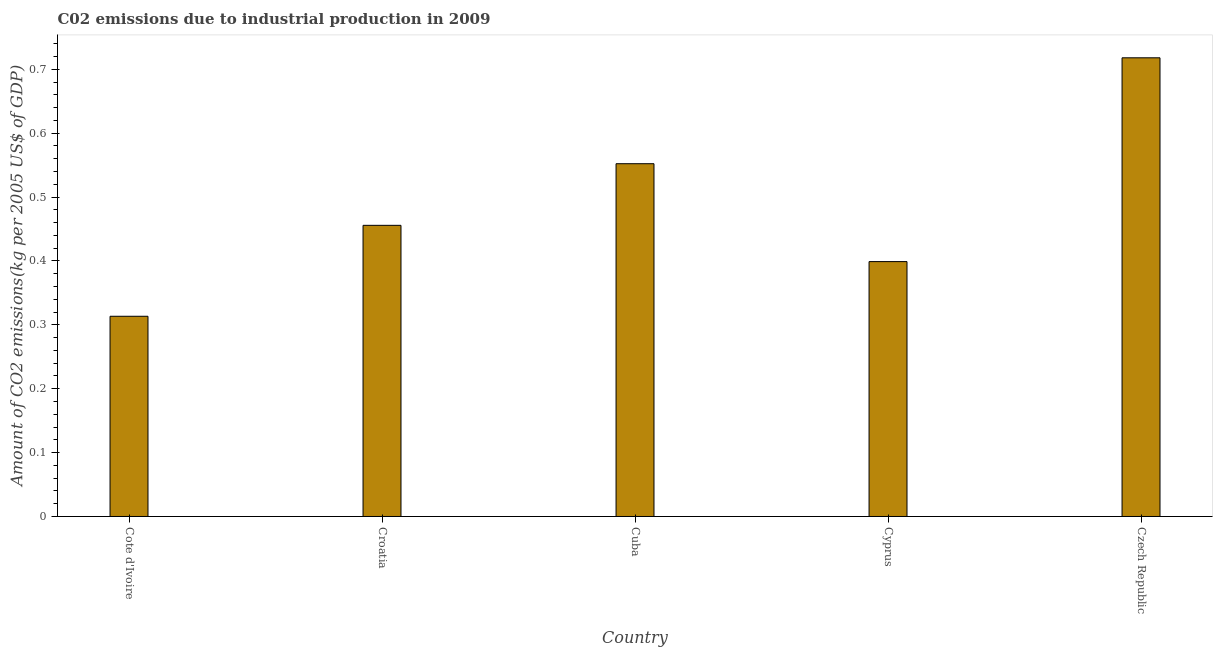Does the graph contain any zero values?
Keep it short and to the point. No. Does the graph contain grids?
Ensure brevity in your answer.  No. What is the title of the graph?
Offer a very short reply. C02 emissions due to industrial production in 2009. What is the label or title of the X-axis?
Ensure brevity in your answer.  Country. What is the label or title of the Y-axis?
Provide a short and direct response. Amount of CO2 emissions(kg per 2005 US$ of GDP). What is the amount of co2 emissions in Cyprus?
Provide a short and direct response. 0.4. Across all countries, what is the maximum amount of co2 emissions?
Make the answer very short. 0.72. Across all countries, what is the minimum amount of co2 emissions?
Give a very brief answer. 0.31. In which country was the amount of co2 emissions maximum?
Ensure brevity in your answer.  Czech Republic. In which country was the amount of co2 emissions minimum?
Ensure brevity in your answer.  Cote d'Ivoire. What is the sum of the amount of co2 emissions?
Your response must be concise. 2.44. What is the difference between the amount of co2 emissions in Croatia and Cuba?
Your answer should be compact. -0.1. What is the average amount of co2 emissions per country?
Offer a very short reply. 0.49. What is the median amount of co2 emissions?
Make the answer very short. 0.46. What is the ratio of the amount of co2 emissions in Cuba to that in Cyprus?
Offer a very short reply. 1.38. Is the amount of co2 emissions in Cote d'Ivoire less than that in Cyprus?
Offer a terse response. Yes. What is the difference between the highest and the second highest amount of co2 emissions?
Give a very brief answer. 0.17. Is the sum of the amount of co2 emissions in Cyprus and Czech Republic greater than the maximum amount of co2 emissions across all countries?
Offer a very short reply. Yes. In how many countries, is the amount of co2 emissions greater than the average amount of co2 emissions taken over all countries?
Your response must be concise. 2. How many bars are there?
Offer a terse response. 5. What is the difference between two consecutive major ticks on the Y-axis?
Make the answer very short. 0.1. What is the Amount of CO2 emissions(kg per 2005 US$ of GDP) of Cote d'Ivoire?
Ensure brevity in your answer.  0.31. What is the Amount of CO2 emissions(kg per 2005 US$ of GDP) in Croatia?
Offer a very short reply. 0.46. What is the Amount of CO2 emissions(kg per 2005 US$ of GDP) in Cuba?
Give a very brief answer. 0.55. What is the Amount of CO2 emissions(kg per 2005 US$ of GDP) in Cyprus?
Provide a succinct answer. 0.4. What is the Amount of CO2 emissions(kg per 2005 US$ of GDP) in Czech Republic?
Provide a succinct answer. 0.72. What is the difference between the Amount of CO2 emissions(kg per 2005 US$ of GDP) in Cote d'Ivoire and Croatia?
Your response must be concise. -0.14. What is the difference between the Amount of CO2 emissions(kg per 2005 US$ of GDP) in Cote d'Ivoire and Cuba?
Offer a very short reply. -0.24. What is the difference between the Amount of CO2 emissions(kg per 2005 US$ of GDP) in Cote d'Ivoire and Cyprus?
Provide a succinct answer. -0.09. What is the difference between the Amount of CO2 emissions(kg per 2005 US$ of GDP) in Cote d'Ivoire and Czech Republic?
Give a very brief answer. -0.4. What is the difference between the Amount of CO2 emissions(kg per 2005 US$ of GDP) in Croatia and Cuba?
Provide a succinct answer. -0.1. What is the difference between the Amount of CO2 emissions(kg per 2005 US$ of GDP) in Croatia and Cyprus?
Offer a terse response. 0.06. What is the difference between the Amount of CO2 emissions(kg per 2005 US$ of GDP) in Croatia and Czech Republic?
Give a very brief answer. -0.26. What is the difference between the Amount of CO2 emissions(kg per 2005 US$ of GDP) in Cuba and Cyprus?
Ensure brevity in your answer.  0.15. What is the difference between the Amount of CO2 emissions(kg per 2005 US$ of GDP) in Cuba and Czech Republic?
Ensure brevity in your answer.  -0.17. What is the difference between the Amount of CO2 emissions(kg per 2005 US$ of GDP) in Cyprus and Czech Republic?
Offer a very short reply. -0.32. What is the ratio of the Amount of CO2 emissions(kg per 2005 US$ of GDP) in Cote d'Ivoire to that in Croatia?
Keep it short and to the point. 0.69. What is the ratio of the Amount of CO2 emissions(kg per 2005 US$ of GDP) in Cote d'Ivoire to that in Cuba?
Keep it short and to the point. 0.57. What is the ratio of the Amount of CO2 emissions(kg per 2005 US$ of GDP) in Cote d'Ivoire to that in Cyprus?
Give a very brief answer. 0.79. What is the ratio of the Amount of CO2 emissions(kg per 2005 US$ of GDP) in Cote d'Ivoire to that in Czech Republic?
Offer a terse response. 0.44. What is the ratio of the Amount of CO2 emissions(kg per 2005 US$ of GDP) in Croatia to that in Cuba?
Ensure brevity in your answer.  0.82. What is the ratio of the Amount of CO2 emissions(kg per 2005 US$ of GDP) in Croatia to that in Cyprus?
Ensure brevity in your answer.  1.14. What is the ratio of the Amount of CO2 emissions(kg per 2005 US$ of GDP) in Croatia to that in Czech Republic?
Your answer should be compact. 0.64. What is the ratio of the Amount of CO2 emissions(kg per 2005 US$ of GDP) in Cuba to that in Cyprus?
Keep it short and to the point. 1.38. What is the ratio of the Amount of CO2 emissions(kg per 2005 US$ of GDP) in Cuba to that in Czech Republic?
Provide a succinct answer. 0.77. What is the ratio of the Amount of CO2 emissions(kg per 2005 US$ of GDP) in Cyprus to that in Czech Republic?
Make the answer very short. 0.56. 